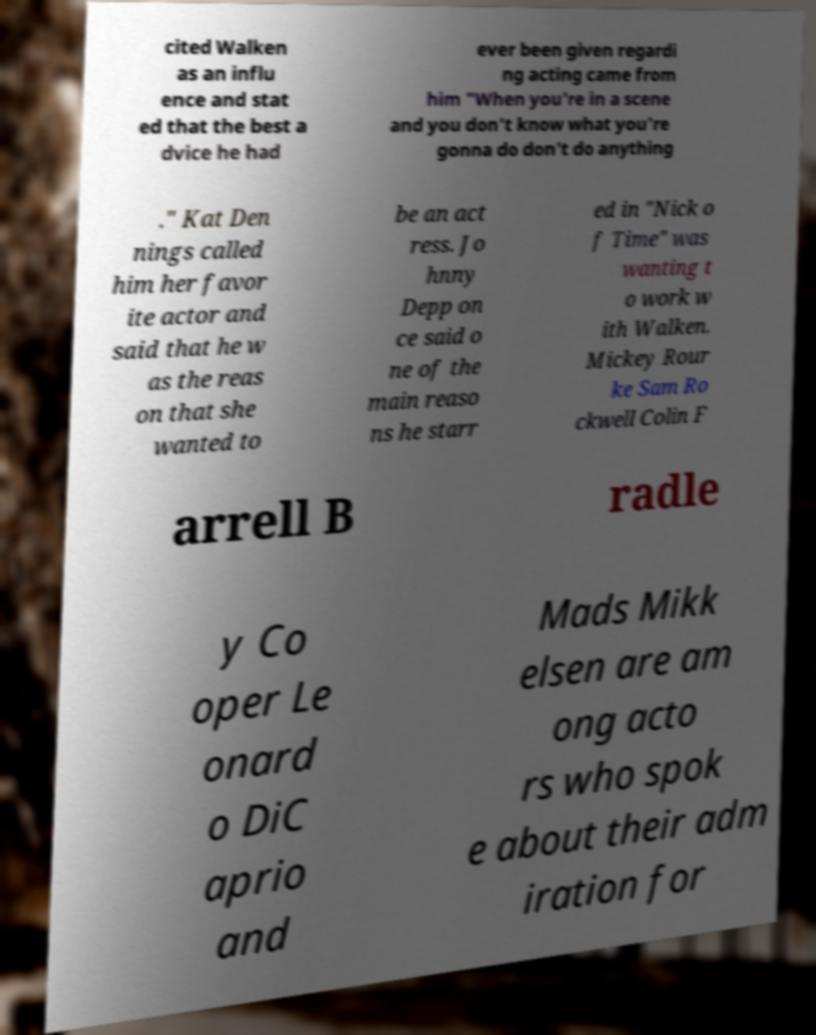Could you assist in decoding the text presented in this image and type it out clearly? cited Walken as an influ ence and stat ed that the best a dvice he had ever been given regardi ng acting came from him "When you're in a scene and you don't know what you're gonna do don't do anything ." Kat Den nings called him her favor ite actor and said that he w as the reas on that she wanted to be an act ress. Jo hnny Depp on ce said o ne of the main reaso ns he starr ed in "Nick o f Time" was wanting t o work w ith Walken. Mickey Rour ke Sam Ro ckwell Colin F arrell B radle y Co oper Le onard o DiC aprio and Mads Mikk elsen are am ong acto rs who spok e about their adm iration for 